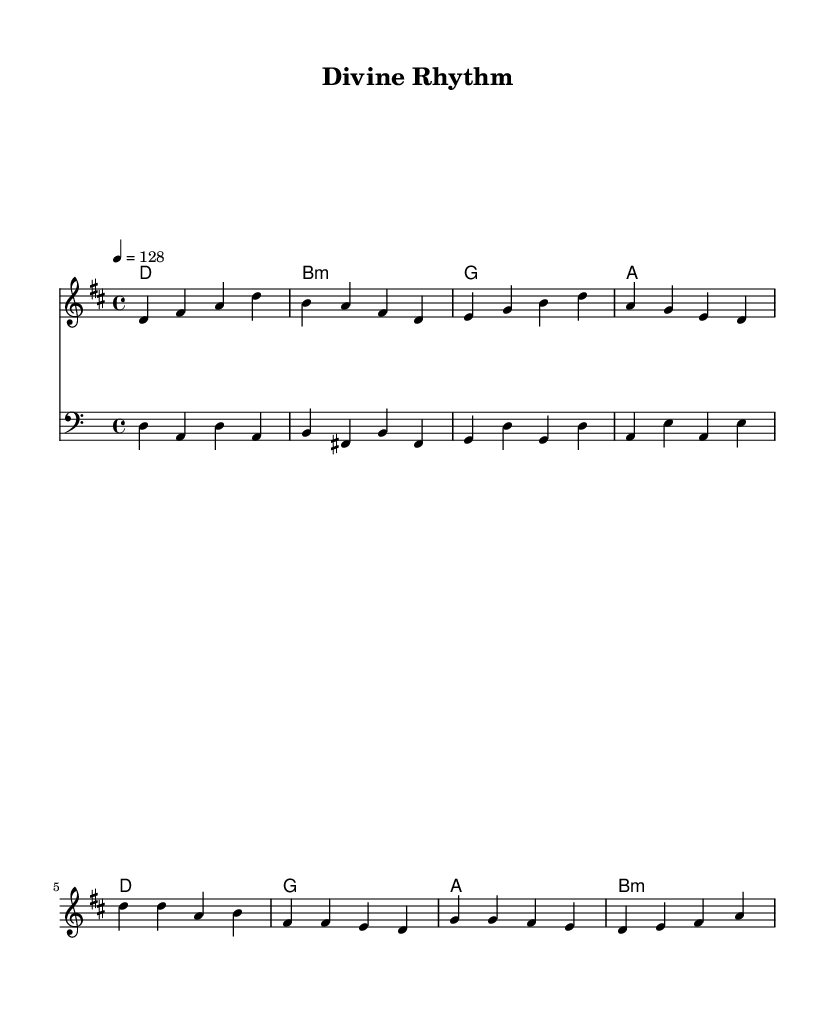What is the key signature of this music? The key signature is D major, identified by the presence of two sharps, F-sharp and C-sharp. This can be seen at the beginning of the staff, indicating the pitches of the notes used throughout the piece.
Answer: D major What is the time signature of this piece? The time signature is 4/4, shown at the beginning of the score. This means there are four beats in each measure, and the quarter note receives one beat.
Answer: 4/4 What is the tempo marking of the music? The tempo marking indicates a speed of 128 beats per minute, noted as "4 = 128" at the start. This tells the performer to play at this brisk pace.
Answer: 128 How many measures are in the verse section? The verse section contains four measures, which can be counted from the initial section of the melody line, presented before the chorus starts.
Answer: 4 What chord is used in the first measure of the chorus? The chord used in the first measure of the chorus is D major, which can be identified in the harmonic part aligned with the melody that starts in the higher octave.
Answer: D Which voice is playing the melody? The melody is played by the staff labeled "melody," which is clearly indicated in the score and contains the highest line of notes.
Answer: Melody What is the last note of the bass line? The last note of the bass line is E, which is seen as the concluding note in the final measure of the bass staff, correlating with the last line of the music.
Answer: E 